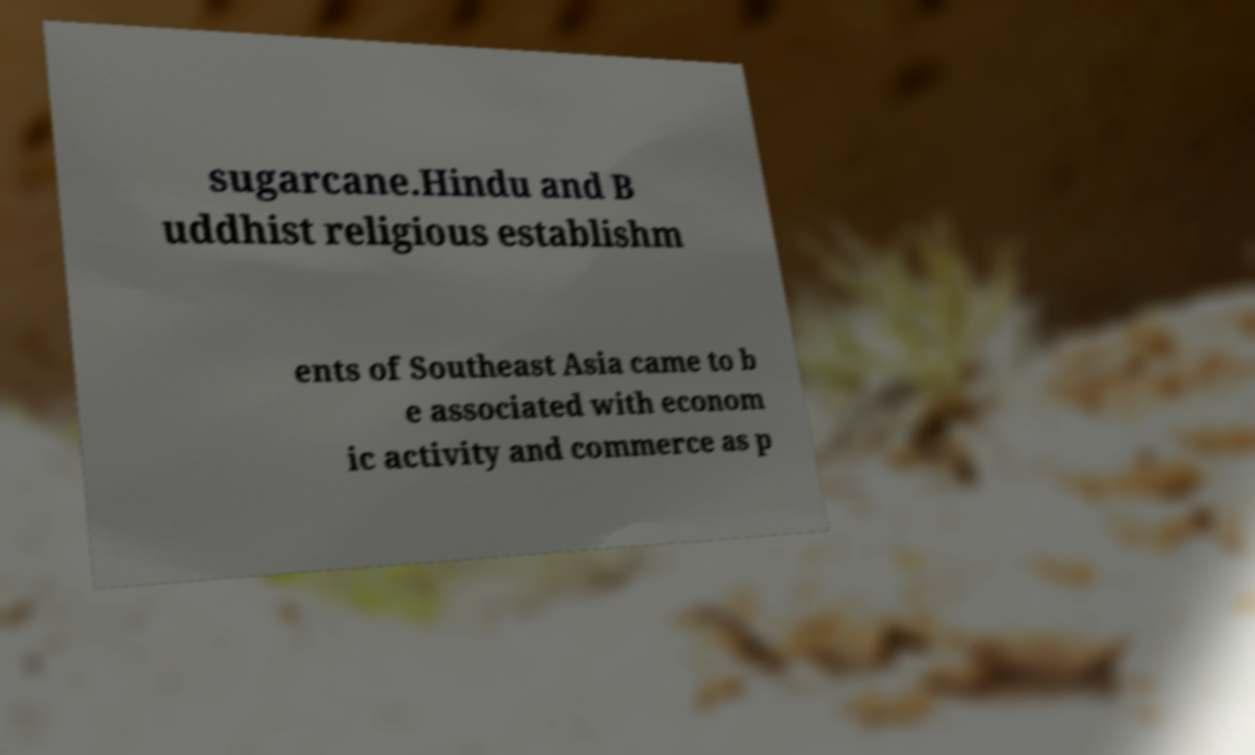Can you read and provide the text displayed in the image?This photo seems to have some interesting text. Can you extract and type it out for me? sugarcane.Hindu and B uddhist religious establishm ents of Southeast Asia came to b e associated with econom ic activity and commerce as p 